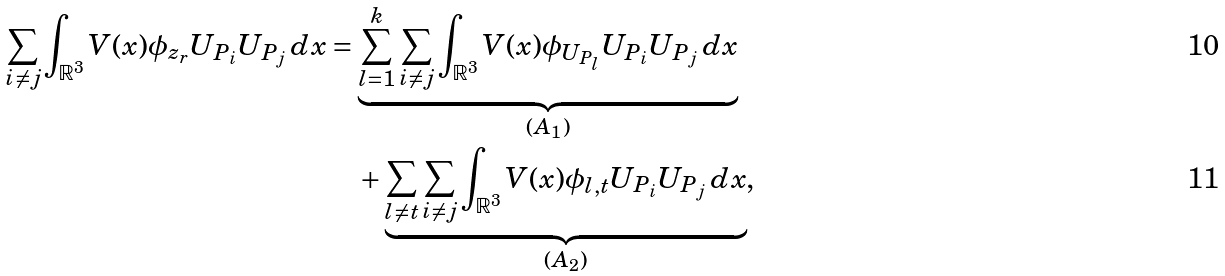<formula> <loc_0><loc_0><loc_500><loc_500>\sum _ { i \neq j } \int _ { \mathbb { R } ^ { 3 } } V ( x ) \phi _ { z _ { r } } U _ { P _ { i } } U _ { P _ { j } } \, d x & = \underbrace { \sum _ { l = 1 } ^ { k } \sum _ { i \neq j } \int _ { \mathbb { R } ^ { 3 } } V ( x ) \phi _ { U _ { P _ { l } } } U _ { P _ { i } } U _ { P _ { j } } \, d x } _ { ( A _ { 1 } ) } \\ & \quad + \underbrace { \sum _ { l \neq t } \sum _ { i \neq j } \int _ { \mathbb { R } ^ { 3 } } V ( x ) \phi _ { l , t } U _ { P _ { i } } U _ { P _ { j } } \, d x } _ { ( A _ { 2 } ) } ,</formula> 